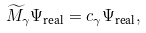<formula> <loc_0><loc_0><loc_500><loc_500>\widetilde { M } _ { \gamma } \Psi _ { \text {real} } = c _ { \gamma } \Psi _ { \text {real} } ,</formula> 